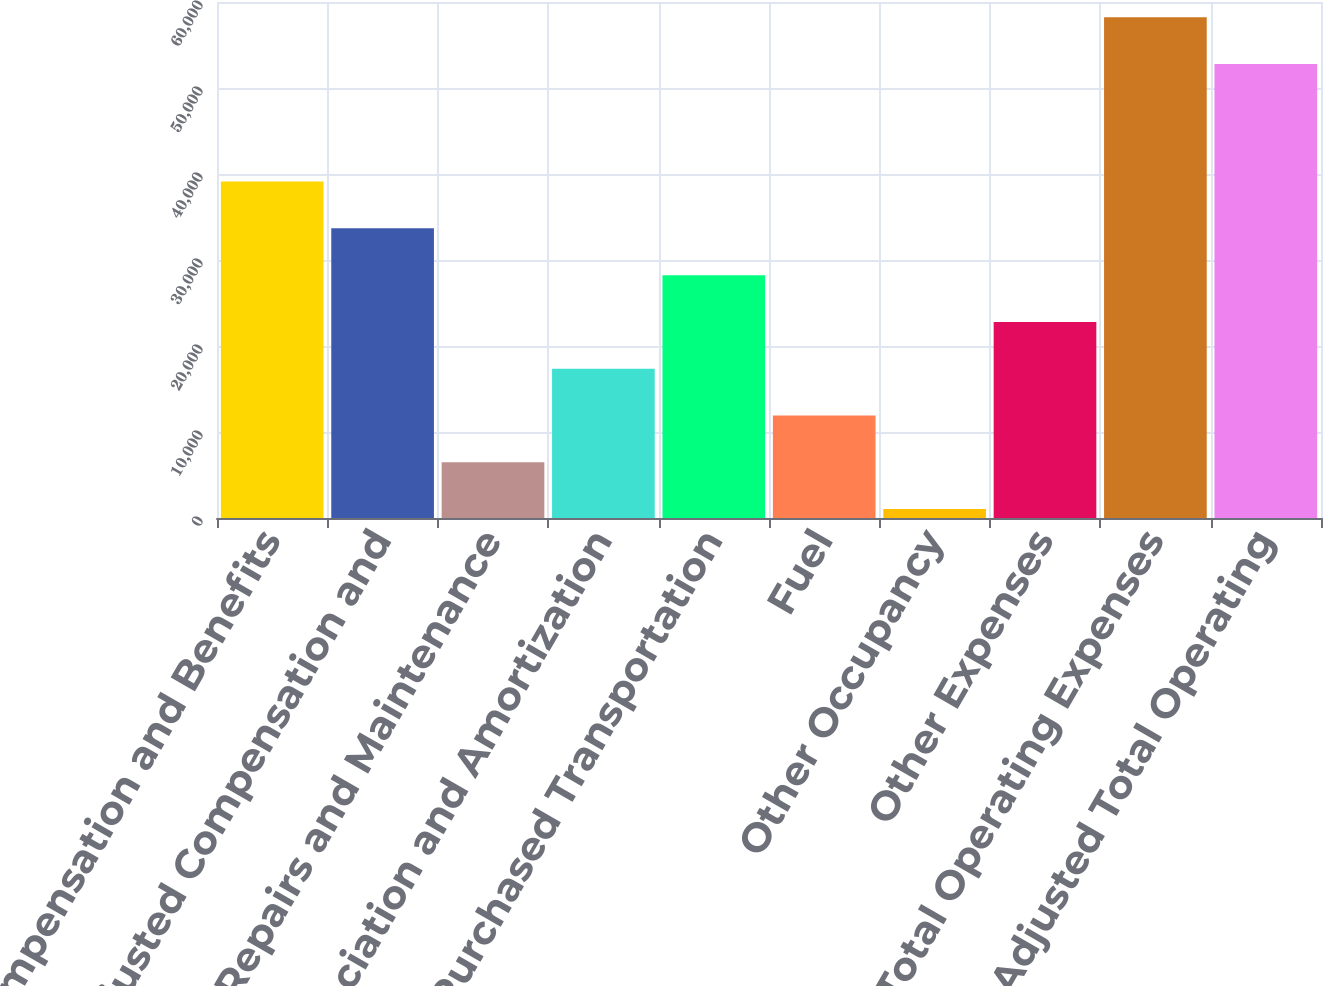<chart> <loc_0><loc_0><loc_500><loc_500><bar_chart><fcel>Compensation and Benefits<fcel>Adjusted Compensation and<fcel>Repairs and Maintenance<fcel>Depreciation and Amortization<fcel>Purchased Transportation<fcel>Fuel<fcel>Other Occupancy<fcel>Other Expenses<fcel>Total Operating Expenses<fcel>Adjusted Total Operating<nl><fcel>39118.4<fcel>33678.2<fcel>6477.2<fcel>17357.6<fcel>28238<fcel>11917.4<fcel>1037<fcel>22797.8<fcel>58228.2<fcel>52788<nl></chart> 